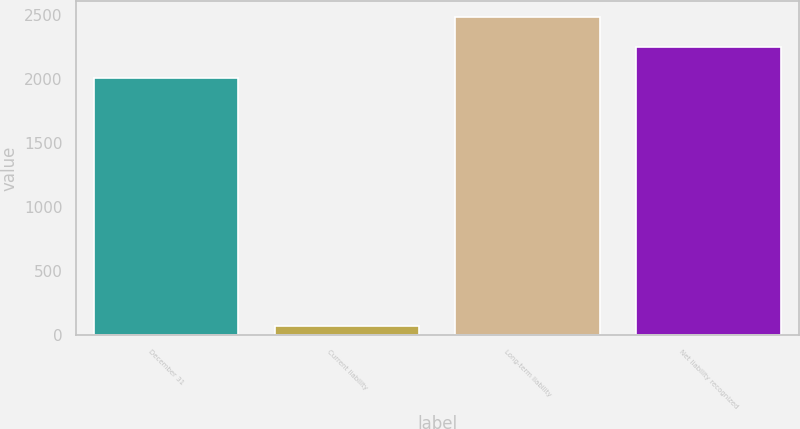Convert chart. <chart><loc_0><loc_0><loc_500><loc_500><bar_chart><fcel>December 31<fcel>Current liability<fcel>Long-term liability<fcel>Net liability recognized<nl><fcel>2012<fcel>73<fcel>2483.6<fcel>2247.8<nl></chart> 